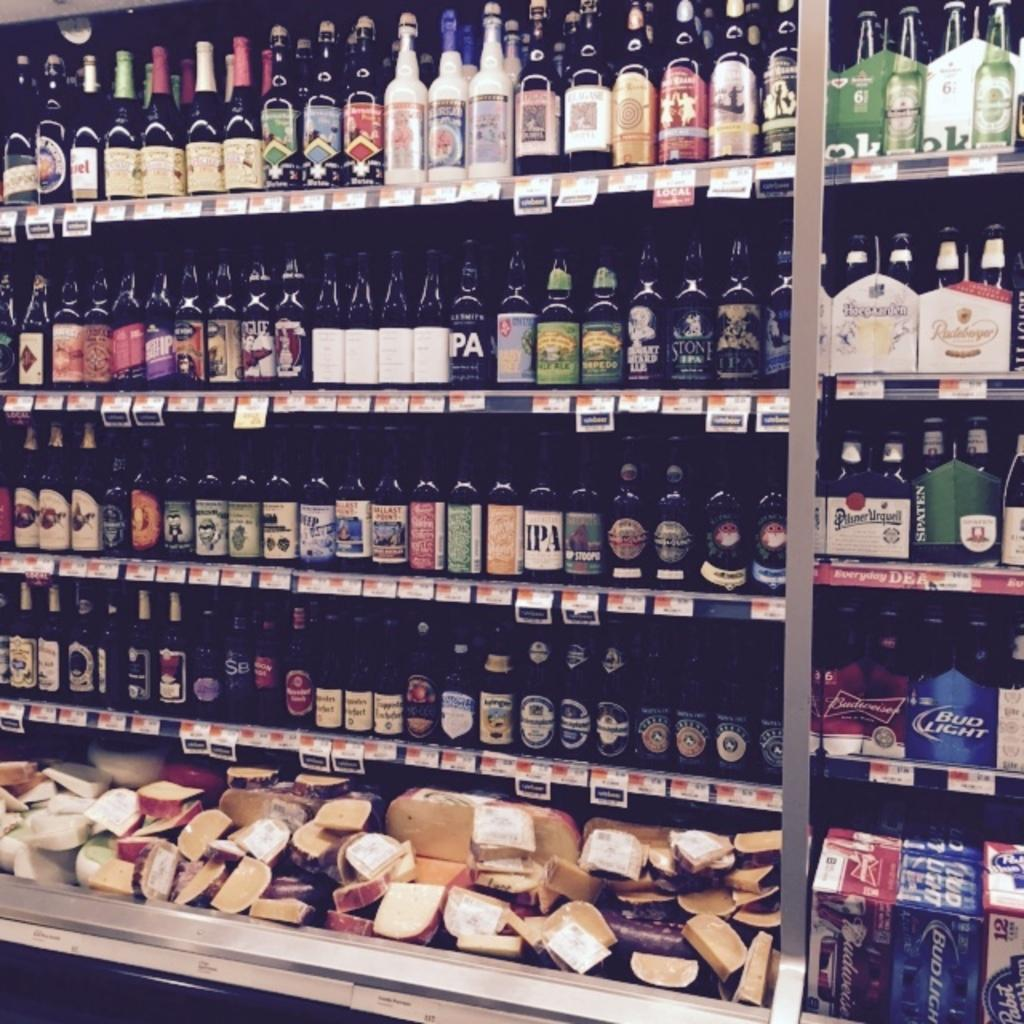<image>
Describe the image concisely. Alcohol store that sells Bud Light near the bottom. 